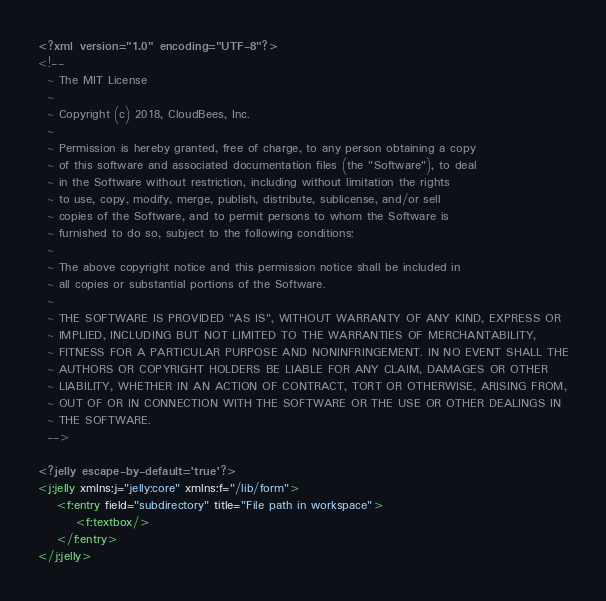Convert code to text. <code><loc_0><loc_0><loc_500><loc_500><_XML_><?xml version="1.0" encoding="UTF-8"?>
<!--
  ~ The MIT License
  ~
  ~ Copyright (c) 2018, CloudBees, Inc.
  ~
  ~ Permission is hereby granted, free of charge, to any person obtaining a copy
  ~ of this software and associated documentation files (the "Software"), to deal
  ~ in the Software without restriction, including without limitation the rights
  ~ to use, copy, modify, merge, publish, distribute, sublicense, and/or sell
  ~ copies of the Software, and to permit persons to whom the Software is
  ~ furnished to do so, subject to the following conditions:
  ~
  ~ The above copyright notice and this permission notice shall be included in
  ~ all copies or substantial portions of the Software.
  ~
  ~ THE SOFTWARE IS PROVIDED "AS IS", WITHOUT WARRANTY OF ANY KIND, EXPRESS OR
  ~ IMPLIED, INCLUDING BUT NOT LIMITED TO THE WARRANTIES OF MERCHANTABILITY,
  ~ FITNESS FOR A PARTICULAR PURPOSE AND NONINFRINGEMENT. IN NO EVENT SHALL THE
  ~ AUTHORS OR COPYRIGHT HOLDERS BE LIABLE FOR ANY CLAIM, DAMAGES OR OTHER
  ~ LIABILITY, WHETHER IN AN ACTION OF CONTRACT, TORT OR OTHERWISE, ARISING FROM,
  ~ OUT OF OR IN CONNECTION WITH THE SOFTWARE OR THE USE OR OTHER DEALINGS IN
  ~ THE SOFTWARE.
  -->

<?jelly escape-by-default='true'?>
<j:jelly xmlns:j="jelly:core" xmlns:f="/lib/form">
    <f:entry field="subdirectory" title="File path in workspace">
        <f:textbox/>
    </f:entry>
</j:jelly>
</code> 